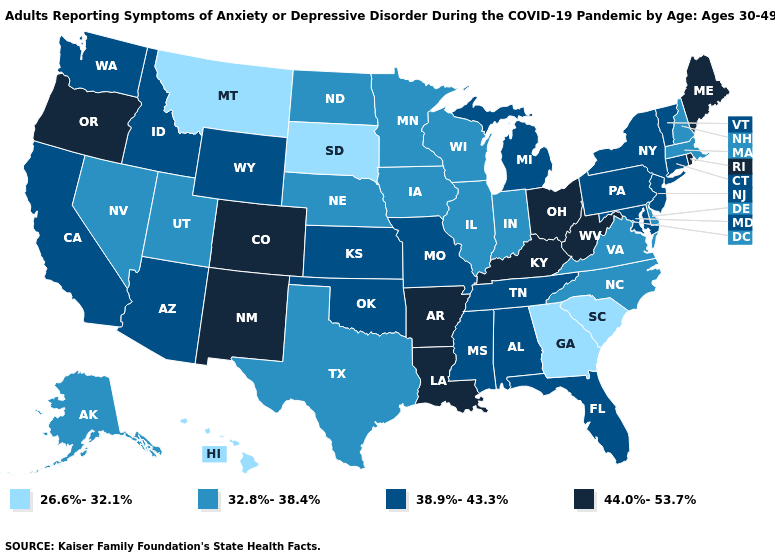What is the lowest value in the USA?
Be succinct. 26.6%-32.1%. Does Tennessee have the lowest value in the South?
Be succinct. No. What is the lowest value in states that border Oregon?
Short answer required. 32.8%-38.4%. Does Indiana have the same value as Nebraska?
Concise answer only. Yes. What is the value of Vermont?
Write a very short answer. 38.9%-43.3%. Does Montana have the lowest value in the West?
Answer briefly. Yes. Name the states that have a value in the range 26.6%-32.1%?
Quick response, please. Georgia, Hawaii, Montana, South Carolina, South Dakota. What is the value of Alaska?
Concise answer only. 32.8%-38.4%. What is the value of Ohio?
Be succinct. 44.0%-53.7%. Is the legend a continuous bar?
Keep it brief. No. How many symbols are there in the legend?
Answer briefly. 4. What is the value of Vermont?
Short answer required. 38.9%-43.3%. Name the states that have a value in the range 38.9%-43.3%?
Give a very brief answer. Alabama, Arizona, California, Connecticut, Florida, Idaho, Kansas, Maryland, Michigan, Mississippi, Missouri, New Jersey, New York, Oklahoma, Pennsylvania, Tennessee, Vermont, Washington, Wyoming. What is the value of Nebraska?
Write a very short answer. 32.8%-38.4%. 